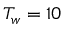<formula> <loc_0><loc_0><loc_500><loc_500>T _ { w } = 1 0</formula> 